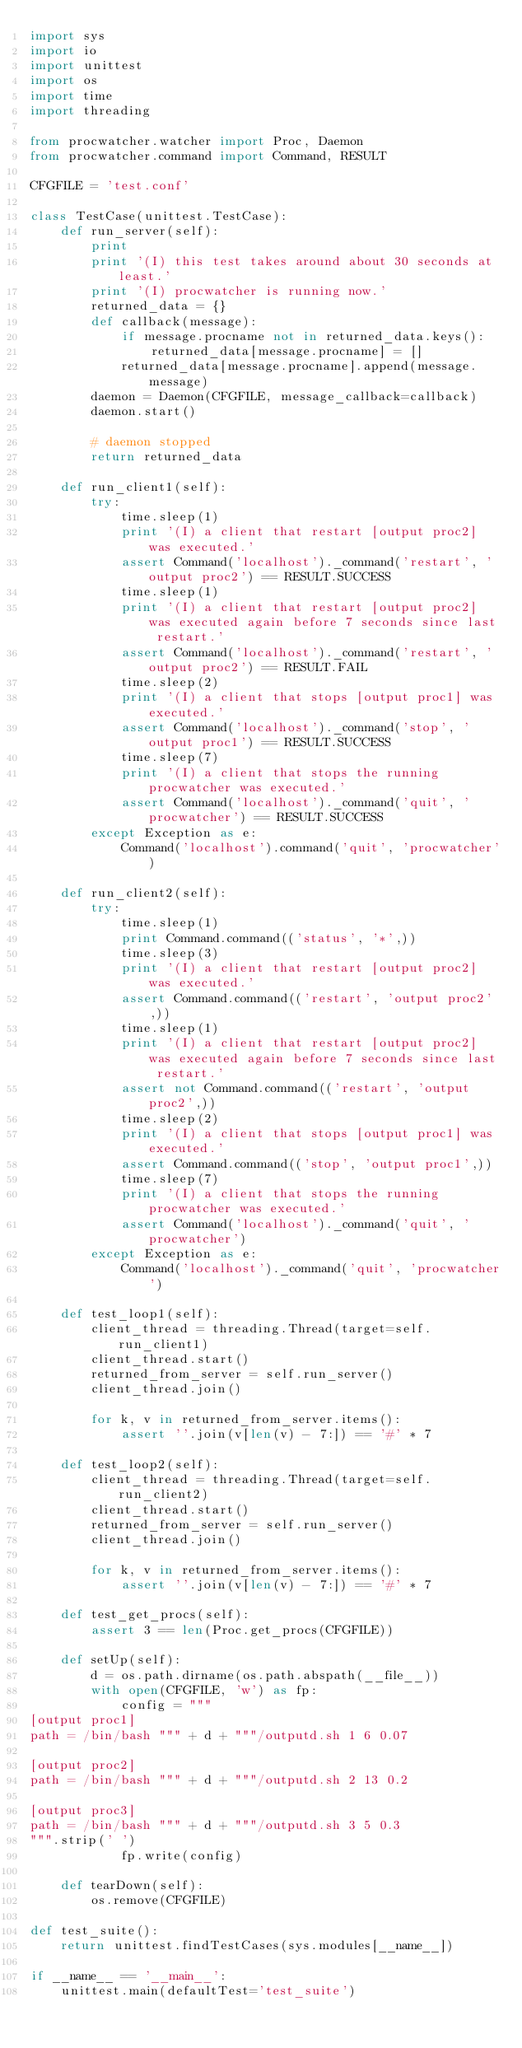Convert code to text. <code><loc_0><loc_0><loc_500><loc_500><_Python_>import sys
import io
import unittest
import os
import time
import threading

from procwatcher.watcher import Proc, Daemon
from procwatcher.command import Command, RESULT

CFGFILE = 'test.conf'

class TestCase(unittest.TestCase):
    def run_server(self):
        print 
        print '(I) this test takes around about 30 seconds at least.'
        print '(I) procwatcher is running now.'
        returned_data = {}
        def callback(message):
            if message.procname not in returned_data.keys():
                returned_data[message.procname] = []
            returned_data[message.procname].append(message.message)
        daemon = Daemon(CFGFILE, message_callback=callback)
        daemon.start()

        # daemon stopped
        return returned_data

    def run_client1(self):
        try:
            time.sleep(1)
            print '(I) a client that restart [output proc2] was executed.'
            assert Command('localhost')._command('restart', 'output proc2') == RESULT.SUCCESS
            time.sleep(1)
            print '(I) a client that restart [output proc2] was executed again before 7 seconds since last restart.'
            assert Command('localhost')._command('restart', 'output proc2') == RESULT.FAIL
            time.sleep(2)
            print '(I) a client that stops [output proc1] was executed.'
            assert Command('localhost')._command('stop', 'output proc1') == RESULT.SUCCESS
            time.sleep(7)
            print '(I) a client that stops the running procwatcher was executed.'
            assert Command('localhost')._command('quit', 'procwatcher') == RESULT.SUCCESS
        except Exception as e:
            Command('localhost').command('quit', 'procwatcher')

    def run_client2(self):
        try:
            time.sleep(1)
            print Command.command(('status', '*',))
            time.sleep(3)
            print '(I) a client that restart [output proc2] was executed.'
            assert Command.command(('restart', 'output proc2',))
            time.sleep(1)
            print '(I) a client that restart [output proc2] was executed again before 7 seconds since last restart.'
            assert not Command.command(('restart', 'output proc2',))
            time.sleep(2)
            print '(I) a client that stops [output proc1] was executed.'
            assert Command.command(('stop', 'output proc1',))
            time.sleep(7)
            print '(I) a client that stops the running procwatcher was executed.'
            assert Command('localhost')._command('quit', 'procwatcher')
        except Exception as e:
            Command('localhost')._command('quit', 'procwatcher')

    def test_loop1(self):
        client_thread = threading.Thread(target=self.run_client1)
        client_thread.start()
        returned_from_server = self.run_server()
        client_thread.join()

        for k, v in returned_from_server.items():
            assert ''.join(v[len(v) - 7:]) == '#' * 7

    def test_loop2(self):
        client_thread = threading.Thread(target=self.run_client2)
        client_thread.start()
        returned_from_server = self.run_server()
        client_thread.join()

        for k, v in returned_from_server.items():
            assert ''.join(v[len(v) - 7:]) == '#' * 7

    def test_get_procs(self):
        assert 3 == len(Proc.get_procs(CFGFILE))

    def setUp(self):
        d = os.path.dirname(os.path.abspath(__file__))
        with open(CFGFILE, 'w') as fp:
            config = """
[output proc1]
path = /bin/bash """ + d + """/outputd.sh 1 6 0.07

[output proc2]
path = /bin/bash """ + d + """/outputd.sh 2 13 0.2

[output proc3]
path = /bin/bash """ + d + """/outputd.sh 3 5 0.3
""".strip(' ')
            fp.write(config)

    def tearDown(self):
        os.remove(CFGFILE)

def test_suite():
    return unittest.findTestCases(sys.modules[__name__])

if __name__ == '__main__':
    unittest.main(defaultTest='test_suite')
</code> 